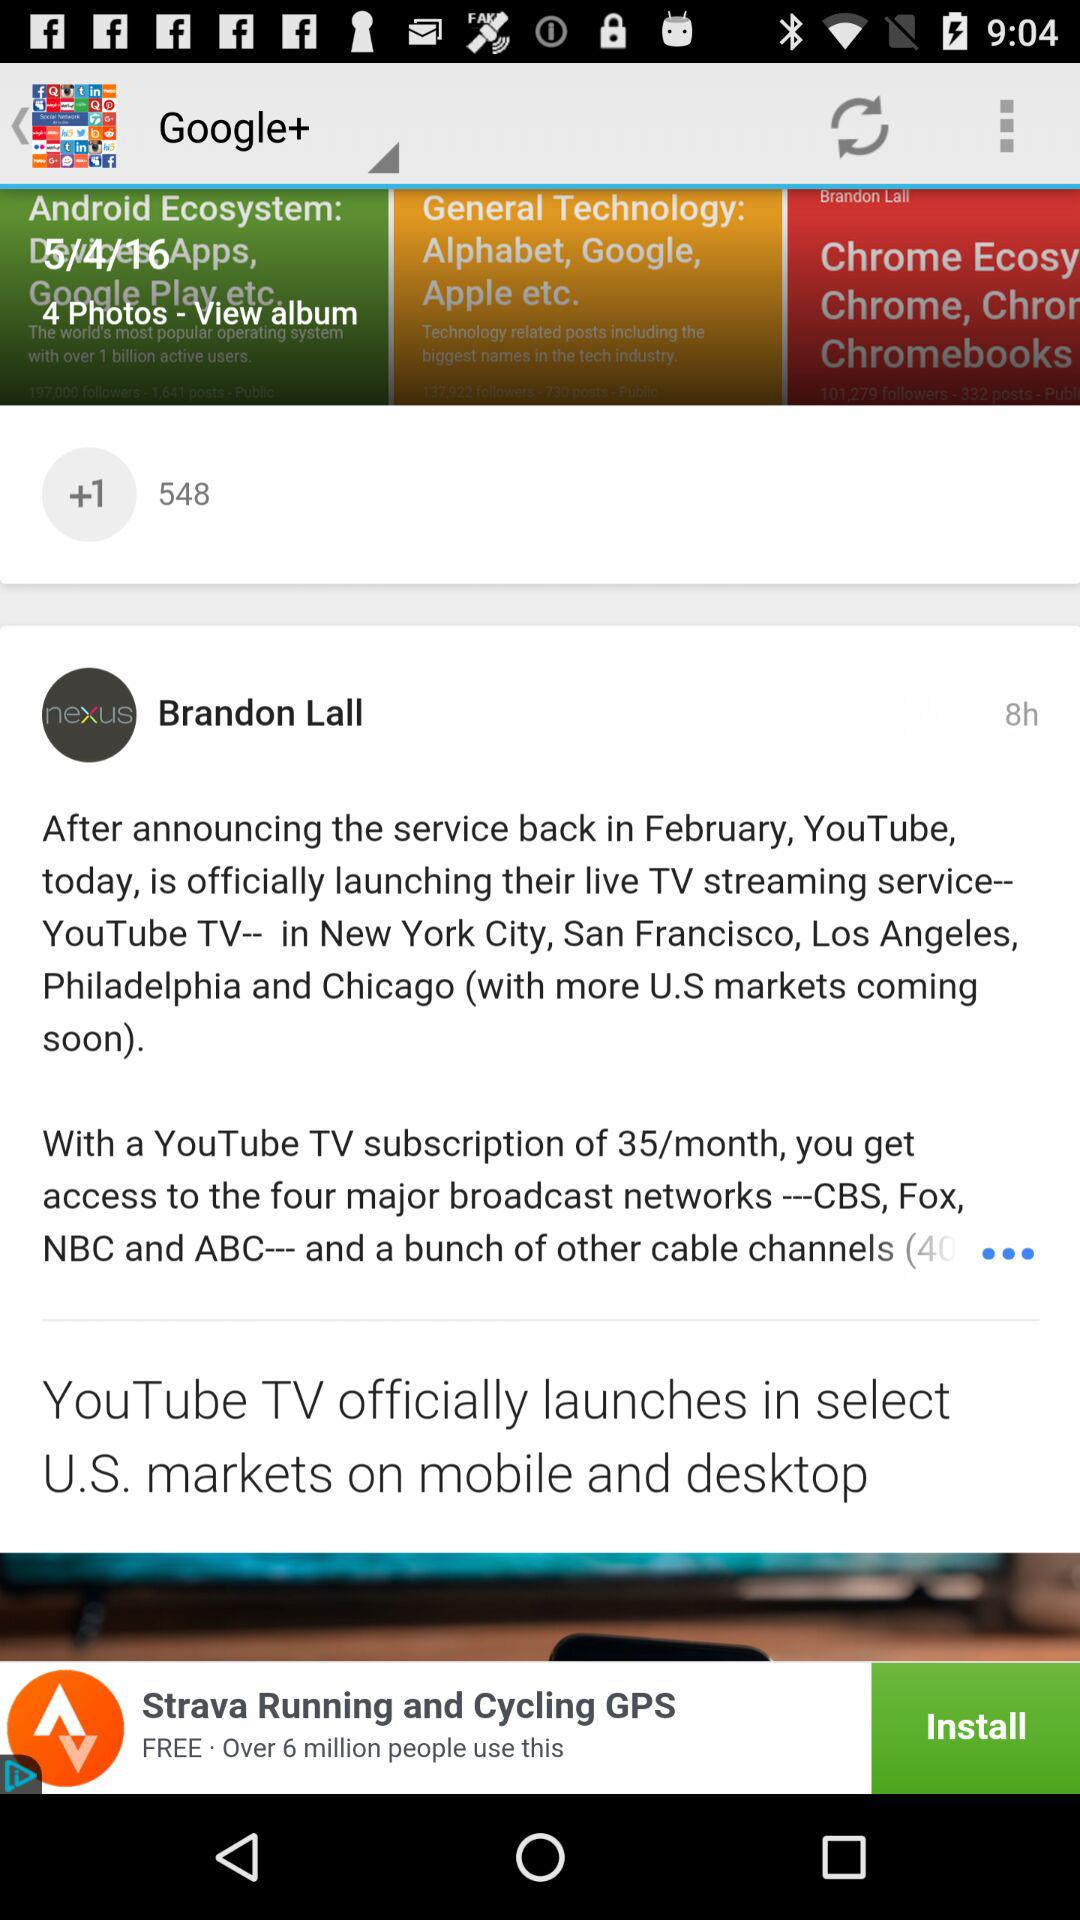How many photos are there in the album? There are 4 photos in the album. 